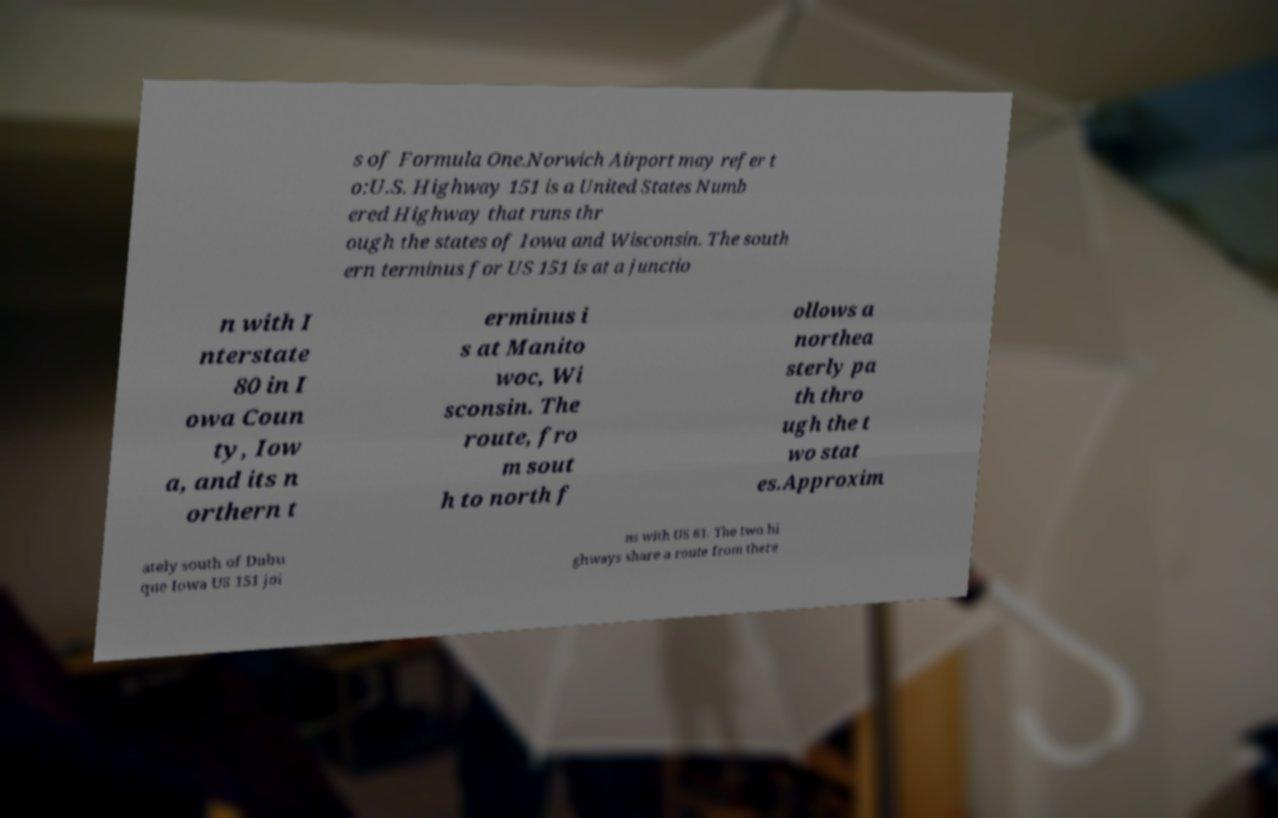Can you accurately transcribe the text from the provided image for me? s of Formula One.Norwich Airport may refer t o:U.S. Highway 151 is a United States Numb ered Highway that runs thr ough the states of Iowa and Wisconsin. The south ern terminus for US 151 is at a junctio n with I nterstate 80 in I owa Coun ty, Iow a, and its n orthern t erminus i s at Manito woc, Wi sconsin. The route, fro m sout h to north f ollows a northea sterly pa th thro ugh the t wo stat es.Approxim ately south of Dubu que Iowa US 151 joi ns with US 61. The two hi ghways share a route from there 